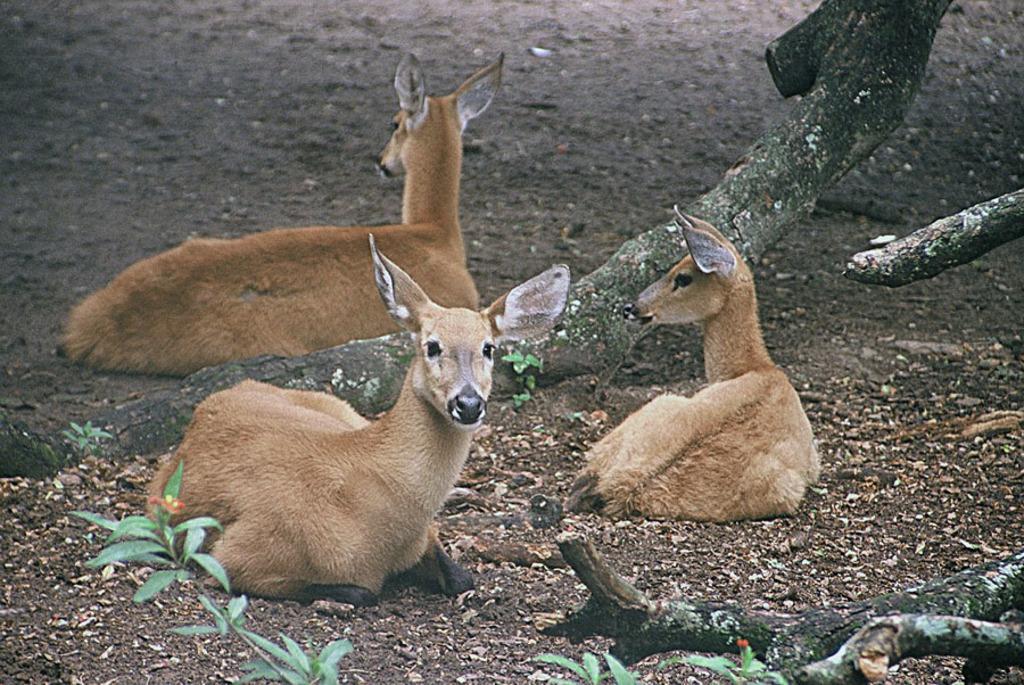Describe this image in one or two sentences. In the center of the image we can see the roe deer are sitting on the ground. In the background of the image we can see the trees and saw dust. 